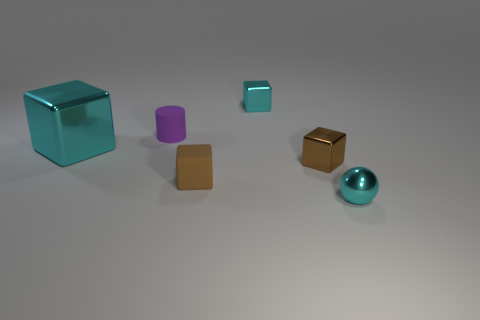Do the rubber cylinder and the tiny metallic cube in front of the big shiny block have the same color?
Make the answer very short. No. There is another block that is the same color as the large metallic cube; what size is it?
Provide a short and direct response. Small. Is the tiny purple thing the same shape as the big cyan object?
Offer a very short reply. No. What size is the shiny thing that is to the left of the tiny metallic thing behind the matte cylinder?
Provide a succinct answer. Large. The other matte thing that is the same shape as the large thing is what color?
Keep it short and to the point. Brown. What number of other tiny rubber balls have the same color as the ball?
Make the answer very short. 0. The cyan metallic ball has what size?
Your answer should be compact. Small. Do the metal ball and the matte cylinder have the same size?
Your answer should be compact. Yes. There is a metal block that is in front of the small purple thing and on the right side of the large cyan metallic thing; what color is it?
Offer a terse response. Brown. How many cyan objects have the same material as the tiny cyan sphere?
Give a very brief answer. 2. 